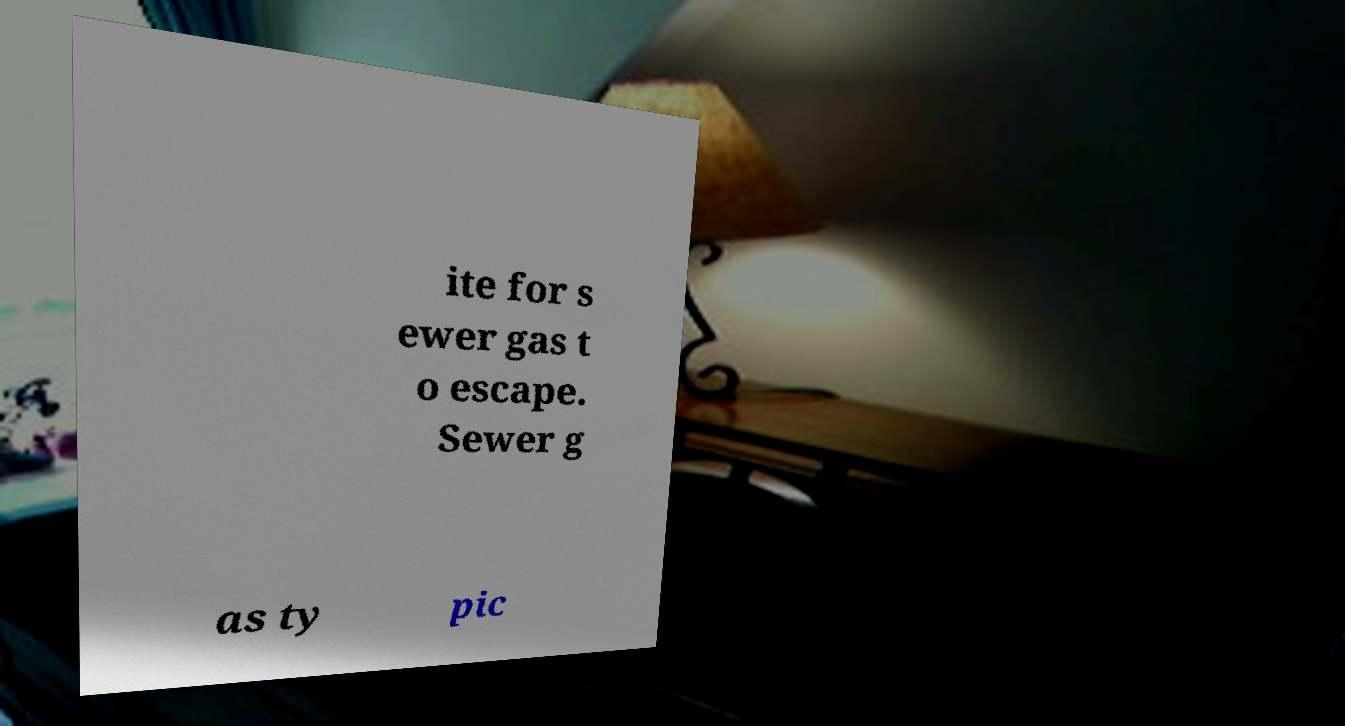There's text embedded in this image that I need extracted. Can you transcribe it verbatim? ite for s ewer gas t o escape. Sewer g as ty pic 